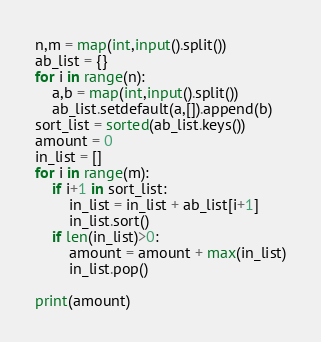Convert code to text. <code><loc_0><loc_0><loc_500><loc_500><_Python_>n,m = map(int,input().split())
ab_list = {}
for i in range(n):
    a,b = map(int,input().split())
    ab_list.setdefault(a,[]).append(b)
sort_list = sorted(ab_list.keys())
amount = 0
in_list = []
for i in range(m):
    if i+1 in sort_list:
        in_list = in_list + ab_list[i+1]
        in_list.sort()
    if len(in_list)>0:
        amount = amount + max(in_list)
        in_list.pop()

print(amount)</code> 